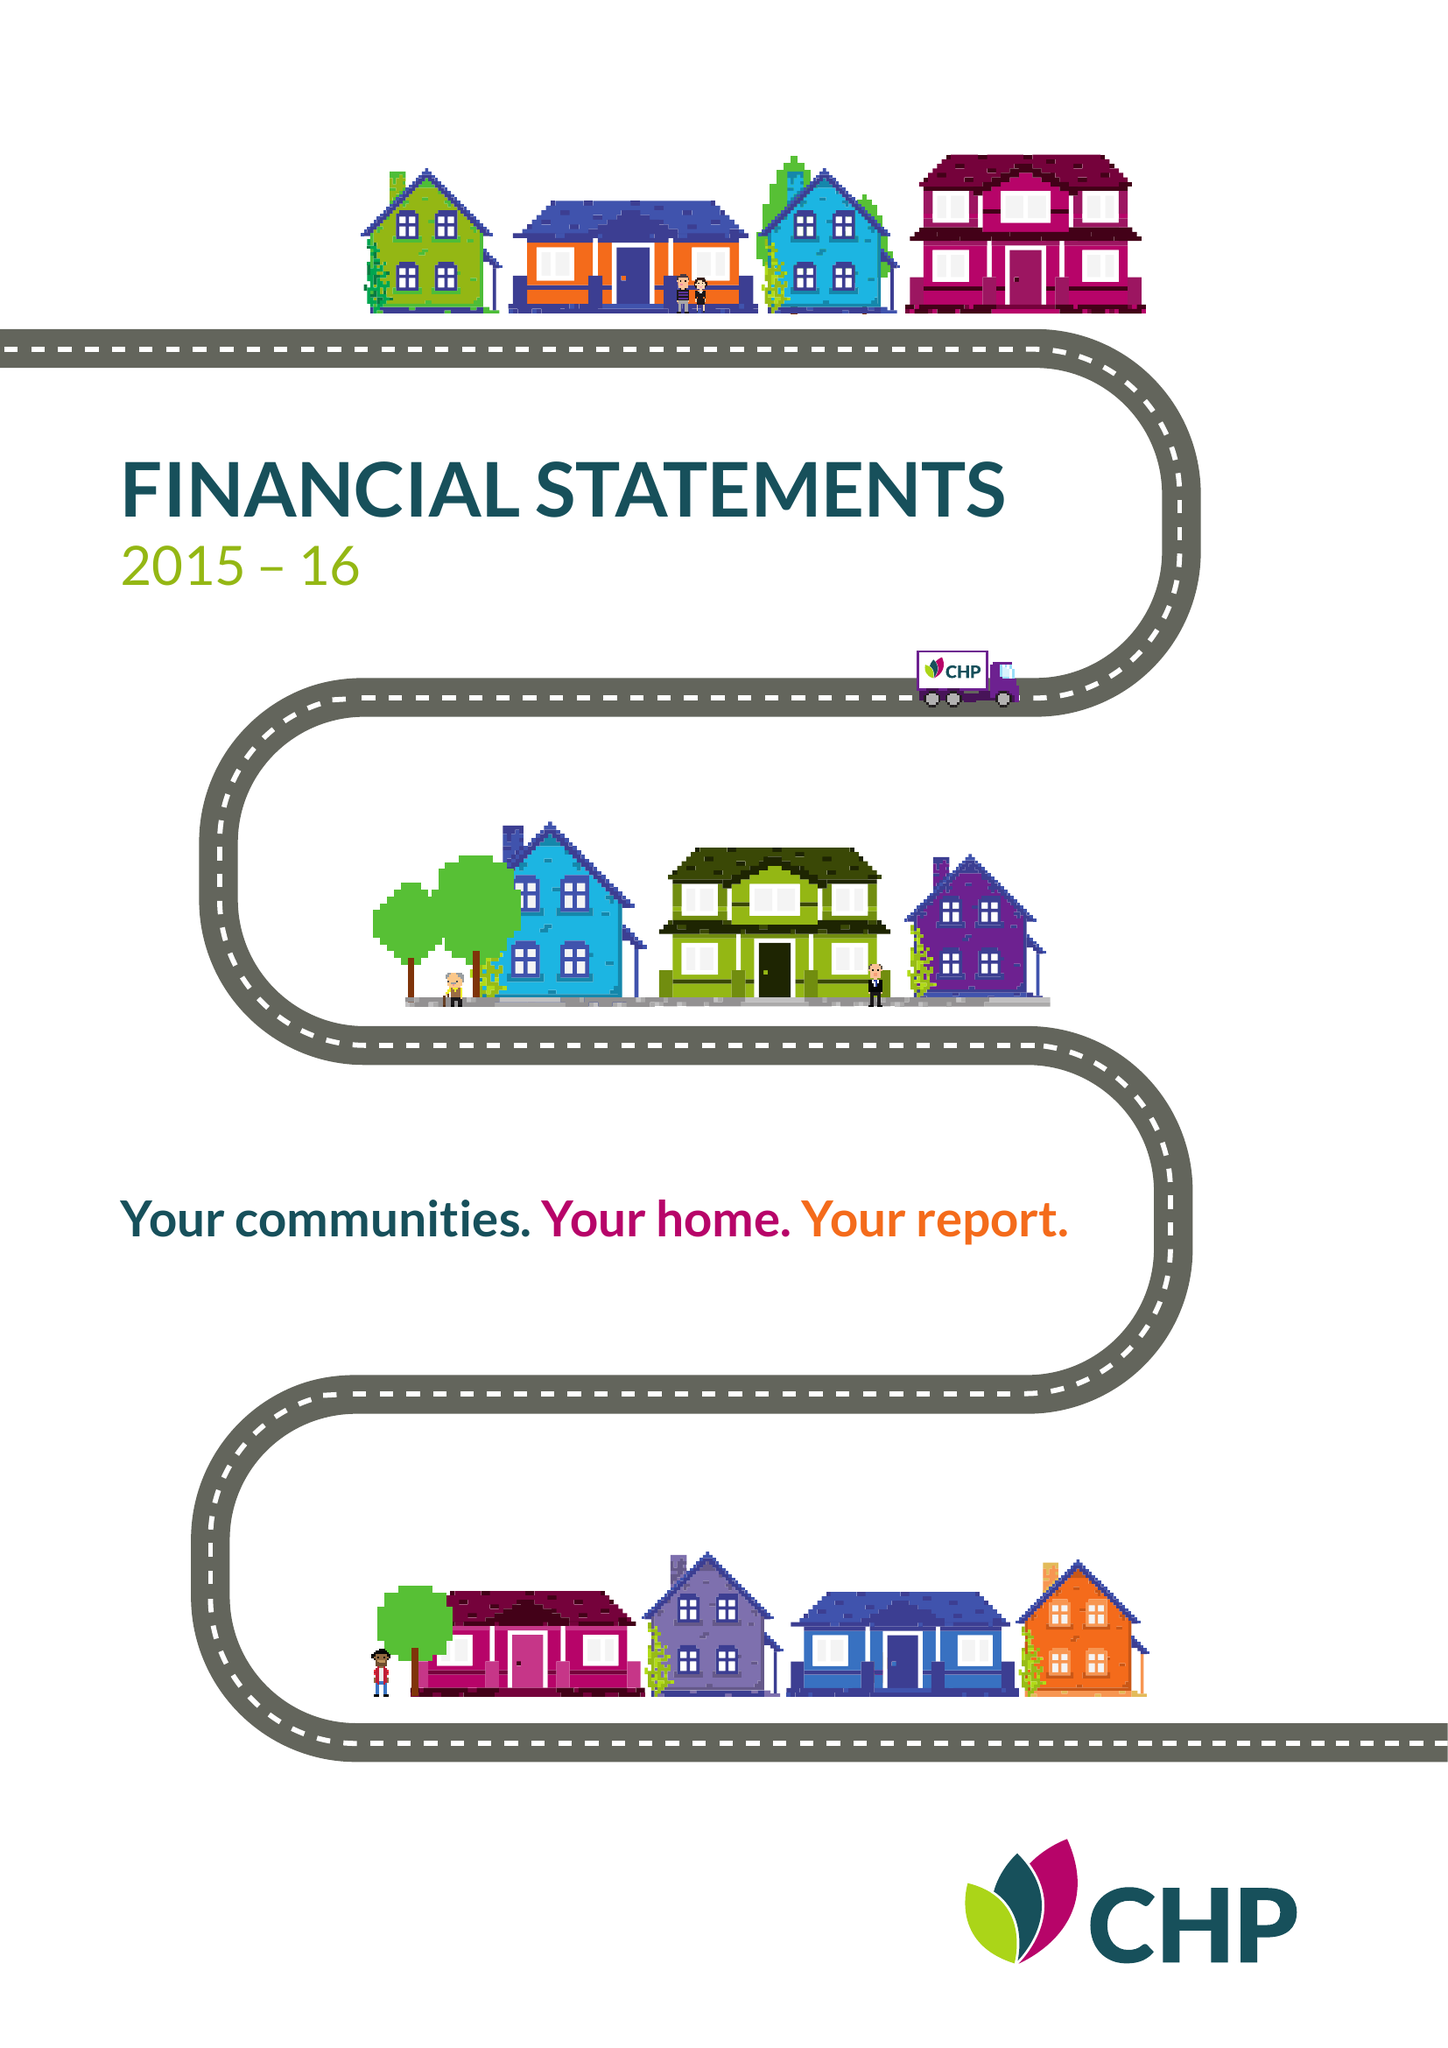What is the value for the address__post_town?
Answer the question using a single word or phrase. CHELMSFORD 